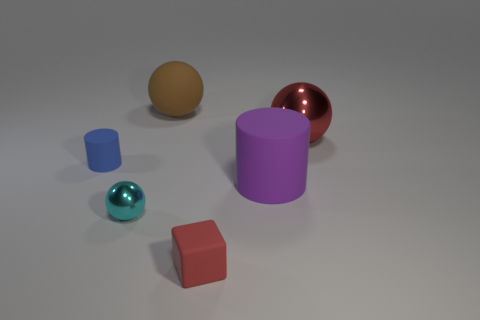Subtract all large spheres. How many spheres are left? 1 Add 2 big red rubber things. How many objects exist? 8 Subtract 1 spheres. How many spheres are left? 2 Subtract all blocks. How many objects are left? 5 Add 5 large red metal blocks. How many large red metal blocks exist? 5 Subtract 0 yellow cubes. How many objects are left? 6 Subtract all cyan cubes. Subtract all yellow balls. How many cubes are left? 1 Subtract all large shiny balls. Subtract all matte things. How many objects are left? 1 Add 6 large balls. How many large balls are left? 8 